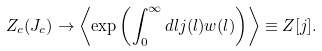Convert formula to latex. <formula><loc_0><loc_0><loc_500><loc_500>Z _ { c } ( J _ { c } ) \rightarrow \left \langle \exp \left ( \int _ { 0 } ^ { \infty } d l j ( l ) w ( l ) \right ) \right \rangle \equiv Z [ j ] .</formula> 